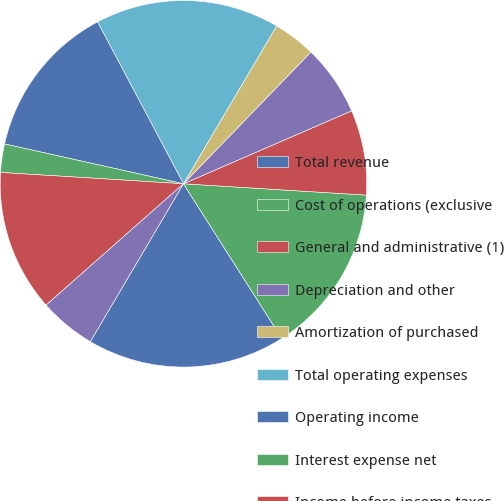Convert chart. <chart><loc_0><loc_0><loc_500><loc_500><pie_chart><fcel>Total revenue<fcel>Cost of operations (exclusive<fcel>General and administrative (1)<fcel>Depreciation and other<fcel>Amortization of purchased<fcel>Total operating expenses<fcel>Operating income<fcel>Interest expense net<fcel>Income before income taxes<fcel>Provision for income taxes<nl><fcel>17.5%<fcel>15.0%<fcel>7.5%<fcel>6.25%<fcel>3.75%<fcel>16.25%<fcel>13.75%<fcel>2.5%<fcel>12.5%<fcel>5.0%<nl></chart> 